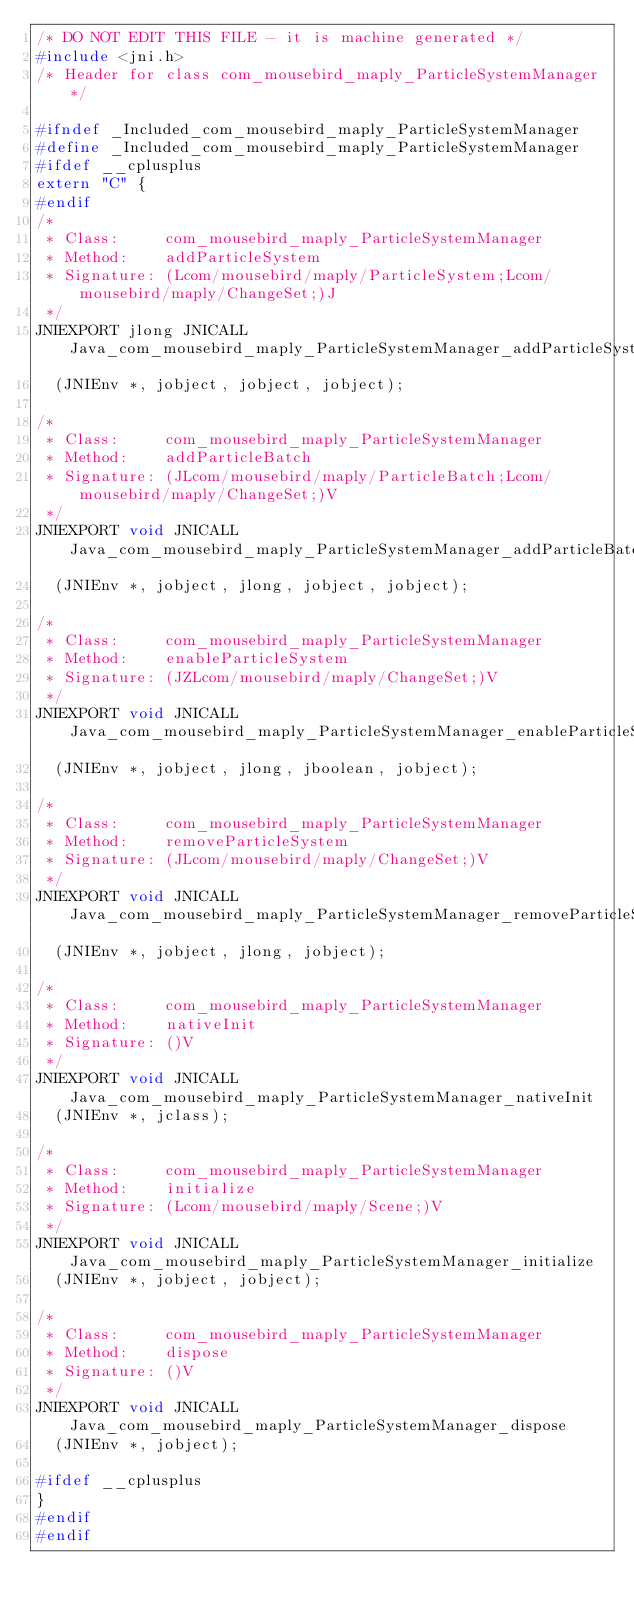<code> <loc_0><loc_0><loc_500><loc_500><_C_>/* DO NOT EDIT THIS FILE - it is machine generated */
#include <jni.h>
/* Header for class com_mousebird_maply_ParticleSystemManager */

#ifndef _Included_com_mousebird_maply_ParticleSystemManager
#define _Included_com_mousebird_maply_ParticleSystemManager
#ifdef __cplusplus
extern "C" {
#endif
/*
 * Class:     com_mousebird_maply_ParticleSystemManager
 * Method:    addParticleSystem
 * Signature: (Lcom/mousebird/maply/ParticleSystem;Lcom/mousebird/maply/ChangeSet;)J
 */
JNIEXPORT jlong JNICALL Java_com_mousebird_maply_ParticleSystemManager_addParticleSystem
  (JNIEnv *, jobject, jobject, jobject);

/*
 * Class:     com_mousebird_maply_ParticleSystemManager
 * Method:    addParticleBatch
 * Signature: (JLcom/mousebird/maply/ParticleBatch;Lcom/mousebird/maply/ChangeSet;)V
 */
JNIEXPORT void JNICALL Java_com_mousebird_maply_ParticleSystemManager_addParticleBatch
  (JNIEnv *, jobject, jlong, jobject, jobject);

/*
 * Class:     com_mousebird_maply_ParticleSystemManager
 * Method:    enableParticleSystem
 * Signature: (JZLcom/mousebird/maply/ChangeSet;)V
 */
JNIEXPORT void JNICALL Java_com_mousebird_maply_ParticleSystemManager_enableParticleSystem
  (JNIEnv *, jobject, jlong, jboolean, jobject);

/*
 * Class:     com_mousebird_maply_ParticleSystemManager
 * Method:    removeParticleSystem
 * Signature: (JLcom/mousebird/maply/ChangeSet;)V
 */
JNIEXPORT void JNICALL Java_com_mousebird_maply_ParticleSystemManager_removeParticleSystem
  (JNIEnv *, jobject, jlong, jobject);

/*
 * Class:     com_mousebird_maply_ParticleSystemManager
 * Method:    nativeInit
 * Signature: ()V
 */
JNIEXPORT void JNICALL Java_com_mousebird_maply_ParticleSystemManager_nativeInit
  (JNIEnv *, jclass);

/*
 * Class:     com_mousebird_maply_ParticleSystemManager
 * Method:    initialize
 * Signature: (Lcom/mousebird/maply/Scene;)V
 */
JNIEXPORT void JNICALL Java_com_mousebird_maply_ParticleSystemManager_initialize
  (JNIEnv *, jobject, jobject);

/*
 * Class:     com_mousebird_maply_ParticleSystemManager
 * Method:    dispose
 * Signature: ()V
 */
JNIEXPORT void JNICALL Java_com_mousebird_maply_ParticleSystemManager_dispose
  (JNIEnv *, jobject);

#ifdef __cplusplus
}
#endif
#endif
</code> 